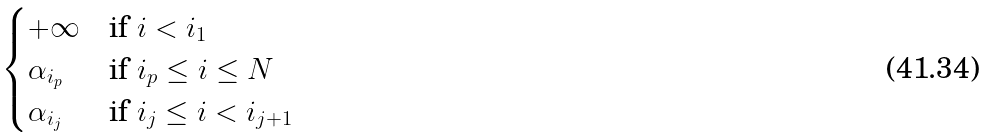Convert formula to latex. <formula><loc_0><loc_0><loc_500><loc_500>\begin{cases} + \infty & \text {if } i < i _ { 1 } \\ \alpha _ { i _ { p } } & \text {if } i _ { p } \leq i \leq N \\ \alpha _ { i _ { j } } & \text {if } i _ { j } \leq i < i _ { j + 1 } \end{cases}</formula> 